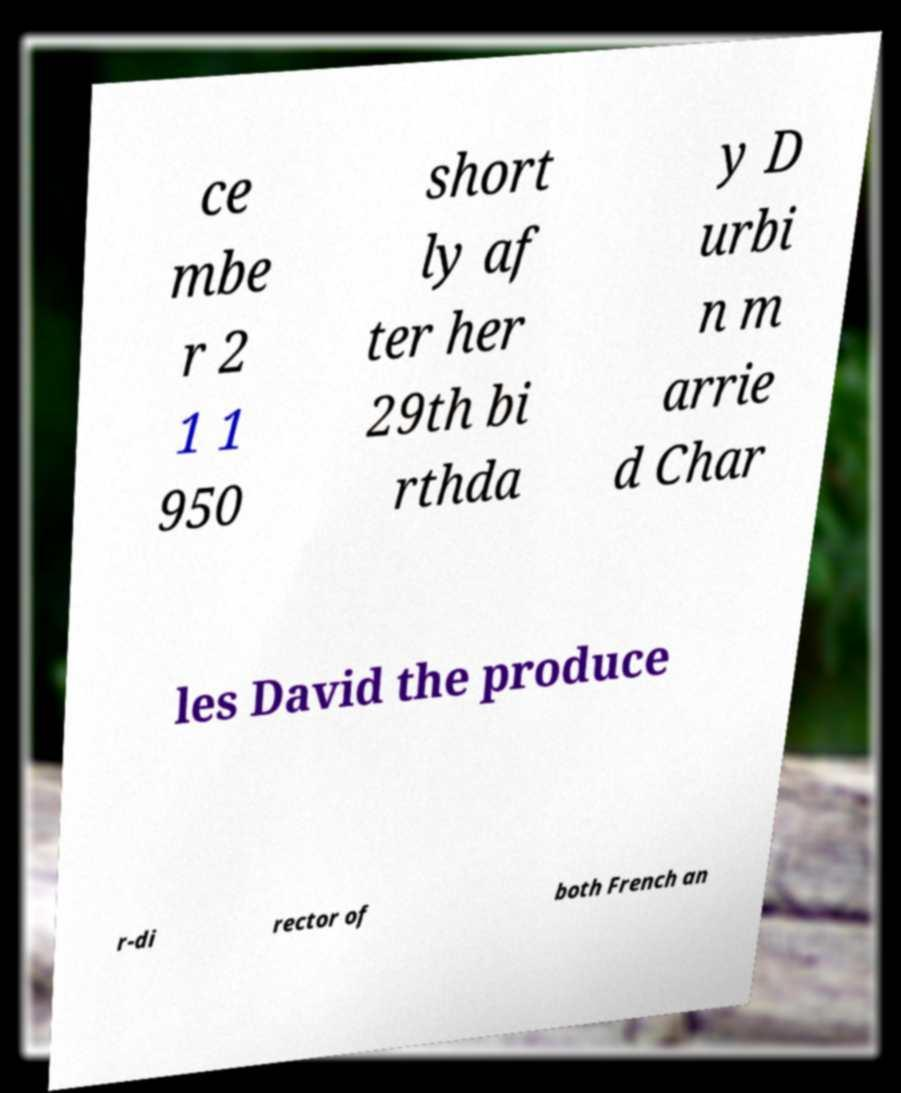Could you assist in decoding the text presented in this image and type it out clearly? ce mbe r 2 1 1 950 short ly af ter her 29th bi rthda y D urbi n m arrie d Char les David the produce r-di rector of both French an 